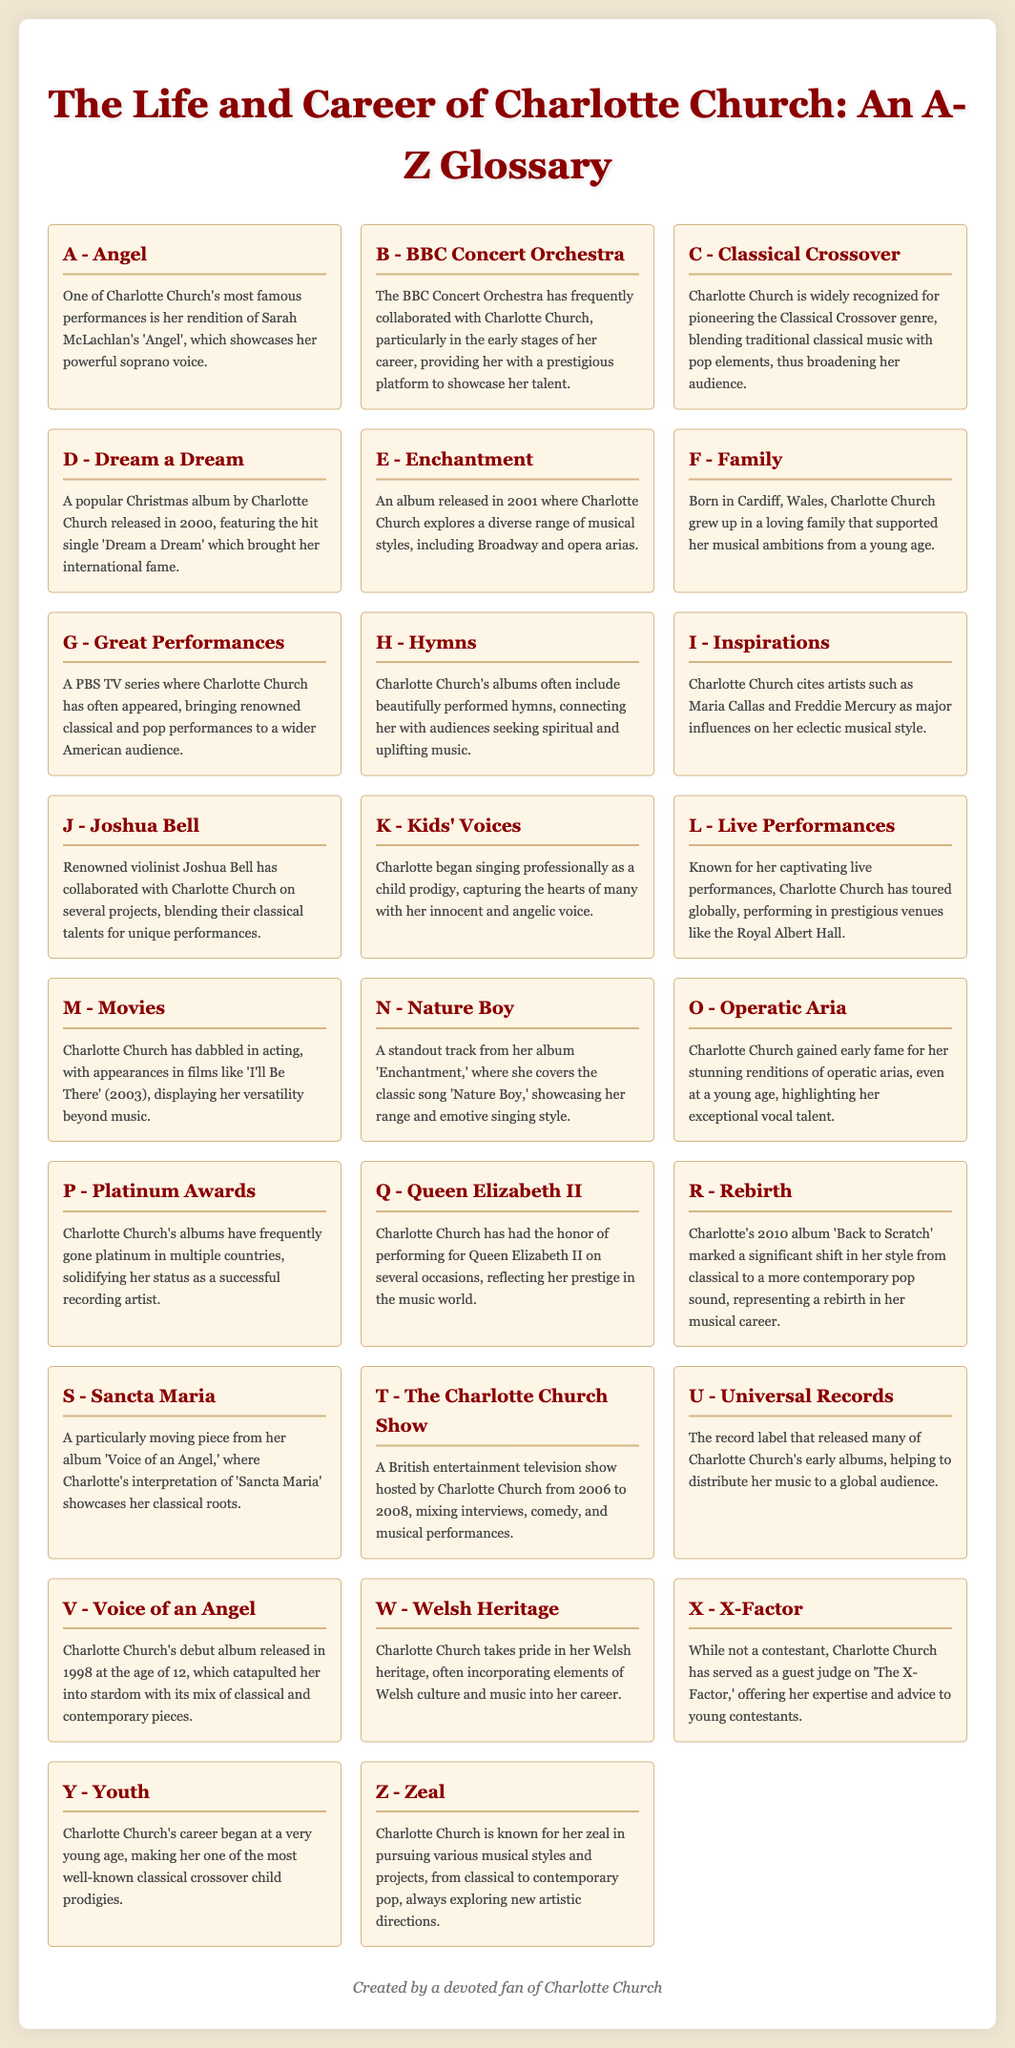What is one of Charlotte Church's most famous performances? The document mentions that one of Charlotte Church's most famous performances is her rendition of 'Angel'.
Answer: Angel What album features the hit single 'Dream a Dream'? The album 'Dream a Dream' is noted for featuring the hit single of the same name, released in 2000.
Answer: Dream a Dream Who collaborated with Charlotte Church on several projects? The document states that renowned violinist Joshua Bell has collaborated with Charlotte Church.
Answer: Joshua Bell In what year was Charlotte Church's debut album released? The document specifies that Charlotte Church's debut album 'Voice of an Angel' was released in 1998.
Answer: 1998 What genre is Charlotte Church widely recognized for pioneering? The document identifies that Charlotte Church is widely recognized for pioneering the Classical Crossover genre.
Answer: Classical Crossover What marked a significant shift in Charlotte Church's musical style? The document notes that her 2010 album 'Back to Scratch' marked a significant shift in her style from classical to contemporary pop.
Answer: Back to Scratch What is Charlotte Church's connection to Queen Elizabeth II? The document indicates that Charlotte Church has performed for Queen Elizabeth II on several occasions.
Answer: Performed for Queen Elizabeth II What show did Charlotte Church host from 2006 to 2008? The document details that 'The Charlotte Church Show' was hosted by Charlotte Church during those years.
Answer: The Charlotte Church Show Which album includes the track 'Nature Boy'? According to the document, the album 'Enchantment' includes the track 'Nature Boy'.
Answer: Enchantment 